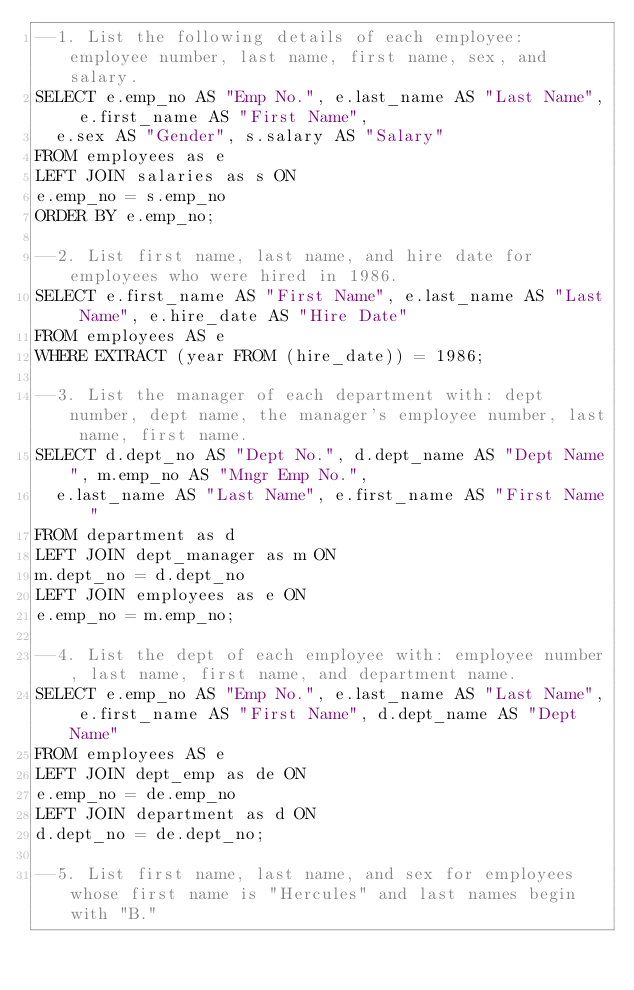<code> <loc_0><loc_0><loc_500><loc_500><_SQL_>--1. List the following details of each employee: employee number, last name, first name, sex, and salary.
SELECT e.emp_no AS "Emp No.", e.last_name AS "Last Name", e.first_name AS "First Name",
	e.sex AS "Gender", s.salary AS "Salary"
FROM employees as e
LEFT JOIN salaries as s ON
e.emp_no = s.emp_no
ORDER BY e.emp_no;

--2. List first name, last name, and hire date for employees who were hired in 1986.
SELECT e.first_name AS "First Name", e.last_name AS "Last Name", e.hire_date AS "Hire Date"
FROM employees AS e
WHERE EXTRACT (year FROM (hire_date)) = 1986;

--3. List the manager of each department with: dept number, dept name, the manager's employee number, last name, first name.
SELECT d.dept_no AS "Dept No.", d.dept_name AS "Dept Name", m.emp_no AS "Mngr Emp No.",
	e.last_name AS "Last Name", e.first_name AS "First Name"
FROM department as d
LEFT JOIN dept_manager as m ON 
m.dept_no = d.dept_no
LEFT JOIN employees as e ON
e.emp_no = m.emp_no;

--4. List the dept of each employee with: employee number, last name, first name, and department name.
SELECT e.emp_no AS "Emp No.", e.last_name AS "Last Name", e.first_name AS "First Name", d.dept_name AS "Dept Name"
FROM employees AS e
LEFT JOIN dept_emp as de ON
e.emp_no = de.emp_no 
LEFT JOIN department as d ON
d.dept_no = de.dept_no;

--5. List first name, last name, and sex for employees whose first name is "Hercules" and last names begin with "B."</code> 